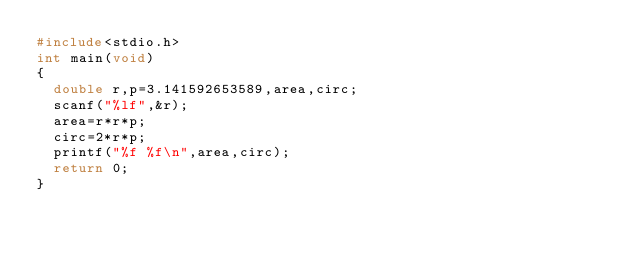Convert code to text. <code><loc_0><loc_0><loc_500><loc_500><_C_>#include<stdio.h>
int main(void)
{
  double r,p=3.141592653589,area,circ;
  scanf("%lf",&r);
  area=r*r*p;
  circ=2*r*p;
  printf("%f %f\n",area,circ);
  return 0;
}

</code> 